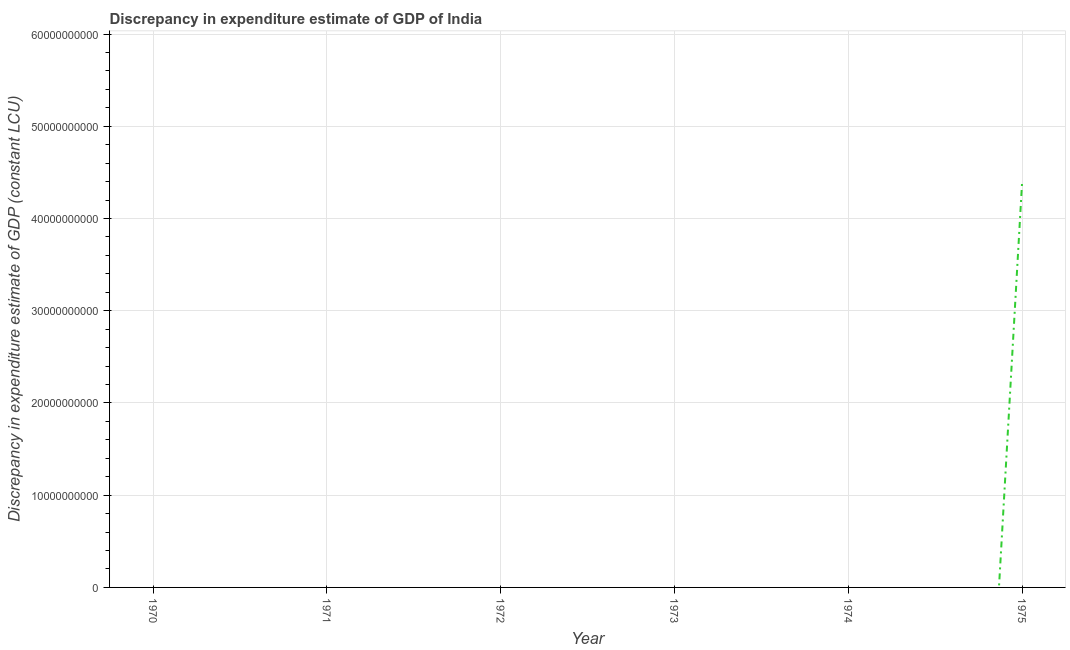Across all years, what is the maximum discrepancy in expenditure estimate of gdp?
Make the answer very short. 4.38e+1. Across all years, what is the minimum discrepancy in expenditure estimate of gdp?
Offer a terse response. 0. In which year was the discrepancy in expenditure estimate of gdp maximum?
Ensure brevity in your answer.  1975. What is the sum of the discrepancy in expenditure estimate of gdp?
Keep it short and to the point. 4.38e+1. What is the average discrepancy in expenditure estimate of gdp per year?
Give a very brief answer. 7.31e+09. What is the difference between the highest and the lowest discrepancy in expenditure estimate of gdp?
Ensure brevity in your answer.  4.38e+1. In how many years, is the discrepancy in expenditure estimate of gdp greater than the average discrepancy in expenditure estimate of gdp taken over all years?
Ensure brevity in your answer.  1. Does the discrepancy in expenditure estimate of gdp monotonically increase over the years?
Give a very brief answer. No. How many years are there in the graph?
Provide a short and direct response. 6. What is the difference between two consecutive major ticks on the Y-axis?
Provide a succinct answer. 1.00e+1. Are the values on the major ticks of Y-axis written in scientific E-notation?
Your answer should be very brief. No. Does the graph contain any zero values?
Make the answer very short. Yes. Does the graph contain grids?
Provide a succinct answer. Yes. What is the title of the graph?
Provide a succinct answer. Discrepancy in expenditure estimate of GDP of India. What is the label or title of the Y-axis?
Keep it short and to the point. Discrepancy in expenditure estimate of GDP (constant LCU). What is the Discrepancy in expenditure estimate of GDP (constant LCU) of 1970?
Your answer should be very brief. 0. What is the Discrepancy in expenditure estimate of GDP (constant LCU) of 1971?
Offer a terse response. 0. What is the Discrepancy in expenditure estimate of GDP (constant LCU) of 1972?
Offer a terse response. 0. What is the Discrepancy in expenditure estimate of GDP (constant LCU) in 1973?
Make the answer very short. 0. What is the Discrepancy in expenditure estimate of GDP (constant LCU) in 1974?
Provide a succinct answer. 0. What is the Discrepancy in expenditure estimate of GDP (constant LCU) of 1975?
Offer a terse response. 4.38e+1. 